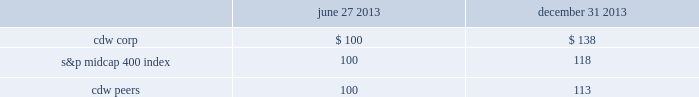
Use of proceeds from registered securities on july 2 , 2013 , the company completed an ipo of its common stock in which it issued and sold 23250000 shares of common stock .
On july 31 , 2013 , the company completed the sale of an additional 3487500 shares of common stock to the underwriters of the ipo pursuant to the underwriters 2019 july 26 , 2013 exercise in full of the overallotment option granted to them in connection with the ipo .
Such shares were registered under the securities act of 1933 , as amended , pursuant to the company 2019s registration statement on form s-1 ( file 333-187472 ) , which was declared effective by the sec on june 26 , 2013 .
The shares of common stock are listed on the nasdaq global select market under the symbol 201ccdw . 201d the company 2019s shares of common stock were sold to the underwriters at a price of $ 17.00 per share in the ipo and upon the exercise of the overallotment option , which together , generated aggregate net proceeds of $ 424.7 million to the company after deducting $ 29.8 million in underwriting discounts , expenses and transaction costs .
Using a portion of the net proceeds from the ipo ( exclusive of proceeds from the exercise of the overallotment option ) , the company paid a $ 24.4 million termination fee to affiliates of madison dearborn partners , llc and providence equity partners , l.l.c .
In connection with the termination of the management services agreement with such entities that was effective upon completion of the ipo , redeemed $ 175.0 million aggregate principal amount of senior secured notes due 2018 , and redeemed $ 146.0 million aggregate principal amount of senior subordinated notes due 2017 .
The redemption price of the senior secured notes due 2018 was 108.0% ( 108.0 % ) of the principal amount redeemed , plus accrued and unpaid interest to the date of redemption .
The company used cash on hand to pay such accrued and unpaid interest .
The redemption price of the senior subordinated notes due 2017 was 106.268% ( 106.268 % ) of the principal amount redeemed , plus accrued and unpaid interest to the date of redemption .
The company used cash on hand to pay such accrued and unpaid interest .
On october 18 , 2013 , proceeds from the overallotment option exercise of $ 56.0 million and cash on hand were used to redeem $ 155.0 million aggregate principal amount of senior subordinated notes due 2017 .
The redemption price of the senior subordinated notes due 2017 was 104.178% ( 104.178 % ) of the principal amount redeemed , plus accrued and unpaid interest to the date of redemption .
The company used cash on hand to pay such redemption premium and accrued and unpaid interest .
J.p .
Morgan securities llc , barclays capital inc .
And goldman , sachs & co .
Acted as joint book-running managers of the ipo and as representatives of the underwriters .
Deutsche bank securities inc .
And morgan stanley & co .
Llc acted as additional book-running managers in the ipo .
Robert w .
Baird & co .
Incorporated , raymond james & associates , inc. , william blair & company , l.l.c. , needham & company , llc , stifel , nicolaus & company , incorporated , loop capital markets llc and the williams capital group , l.p .
Acted as managing underwriters in the ipo. .
How many ipo shares did the company sell in july 2013? 
Computations: (23250000 + 3487500)
Answer: 26737500.0. 
Use of proceeds from registered securities on july 2 , 2013 , the company completed an ipo of its common stock in which it issued and sold 23250000 shares of common stock .
On july 31 , 2013 , the company completed the sale of an additional 3487500 shares of common stock to the underwriters of the ipo pursuant to the underwriters 2019 july 26 , 2013 exercise in full of the overallotment option granted to them in connection with the ipo .
Such shares were registered under the securities act of 1933 , as amended , pursuant to the company 2019s registration statement on form s-1 ( file 333-187472 ) , which was declared effective by the sec on june 26 , 2013 .
The shares of common stock are listed on the nasdaq global select market under the symbol 201ccdw . 201d the company 2019s shares of common stock were sold to the underwriters at a price of $ 17.00 per share in the ipo and upon the exercise of the overallotment option , which together , generated aggregate net proceeds of $ 424.7 million to the company after deducting $ 29.8 million in underwriting discounts , expenses and transaction costs .
Using a portion of the net proceeds from the ipo ( exclusive of proceeds from the exercise of the overallotment option ) , the company paid a $ 24.4 million termination fee to affiliates of madison dearborn partners , llc and providence equity partners , l.l.c .
In connection with the termination of the management services agreement with such entities that was effective upon completion of the ipo , redeemed $ 175.0 million aggregate principal amount of senior secured notes due 2018 , and redeemed $ 146.0 million aggregate principal amount of senior subordinated notes due 2017 .
The redemption price of the senior secured notes due 2018 was 108.0% ( 108.0 % ) of the principal amount redeemed , plus accrued and unpaid interest to the date of redemption .
The company used cash on hand to pay such accrued and unpaid interest .
The redemption price of the senior subordinated notes due 2017 was 106.268% ( 106.268 % ) of the principal amount redeemed , plus accrued and unpaid interest to the date of redemption .
The company used cash on hand to pay such accrued and unpaid interest .
On october 18 , 2013 , proceeds from the overallotment option exercise of $ 56.0 million and cash on hand were used to redeem $ 155.0 million aggregate principal amount of senior subordinated notes due 2017 .
The redemption price of the senior subordinated notes due 2017 was 104.178% ( 104.178 % ) of the principal amount redeemed , plus accrued and unpaid interest to the date of redemption .
The company used cash on hand to pay such redemption premium and accrued and unpaid interest .
J.p .
Morgan securities llc , barclays capital inc .
And goldman , sachs & co .
Acted as joint book-running managers of the ipo and as representatives of the underwriters .
Deutsche bank securities inc .
And morgan stanley & co .
Llc acted as additional book-running managers in the ipo .
Robert w .
Baird & co .
Incorporated , raymond james & associates , inc. , william blair & company , l.l.c. , needham & company , llc , stifel , nicolaus & company , incorporated , loop capital markets llc and the williams capital group , l.p .
Acted as managing underwriters in the ipo. .
What was the total number of shares issued in the ipo including the sale of the additional shares of common stock to the underwriters of the ipo pursuant to the underwriters 2019 july 26 , 2013 exercise in full of the overallotment option grant? 
Computations: (23250000 + 3487500)
Answer: 26737500.0. 